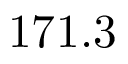Convert formula to latex. <formula><loc_0><loc_0><loc_500><loc_500>1 7 1 . 3</formula> 